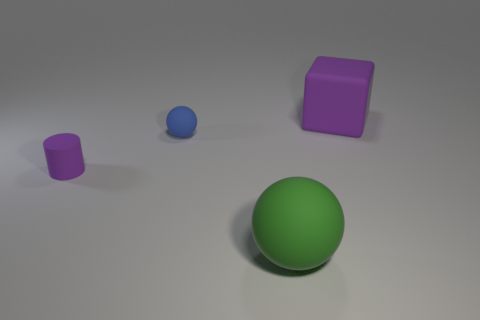Add 1 green matte spheres. How many objects exist? 5 Subtract all cylinders. How many objects are left? 3 Subtract 1 purple blocks. How many objects are left? 3 Subtract all large objects. Subtract all small matte balls. How many objects are left? 1 Add 3 purple matte blocks. How many purple matte blocks are left? 4 Add 2 large blue cubes. How many large blue cubes exist? 2 